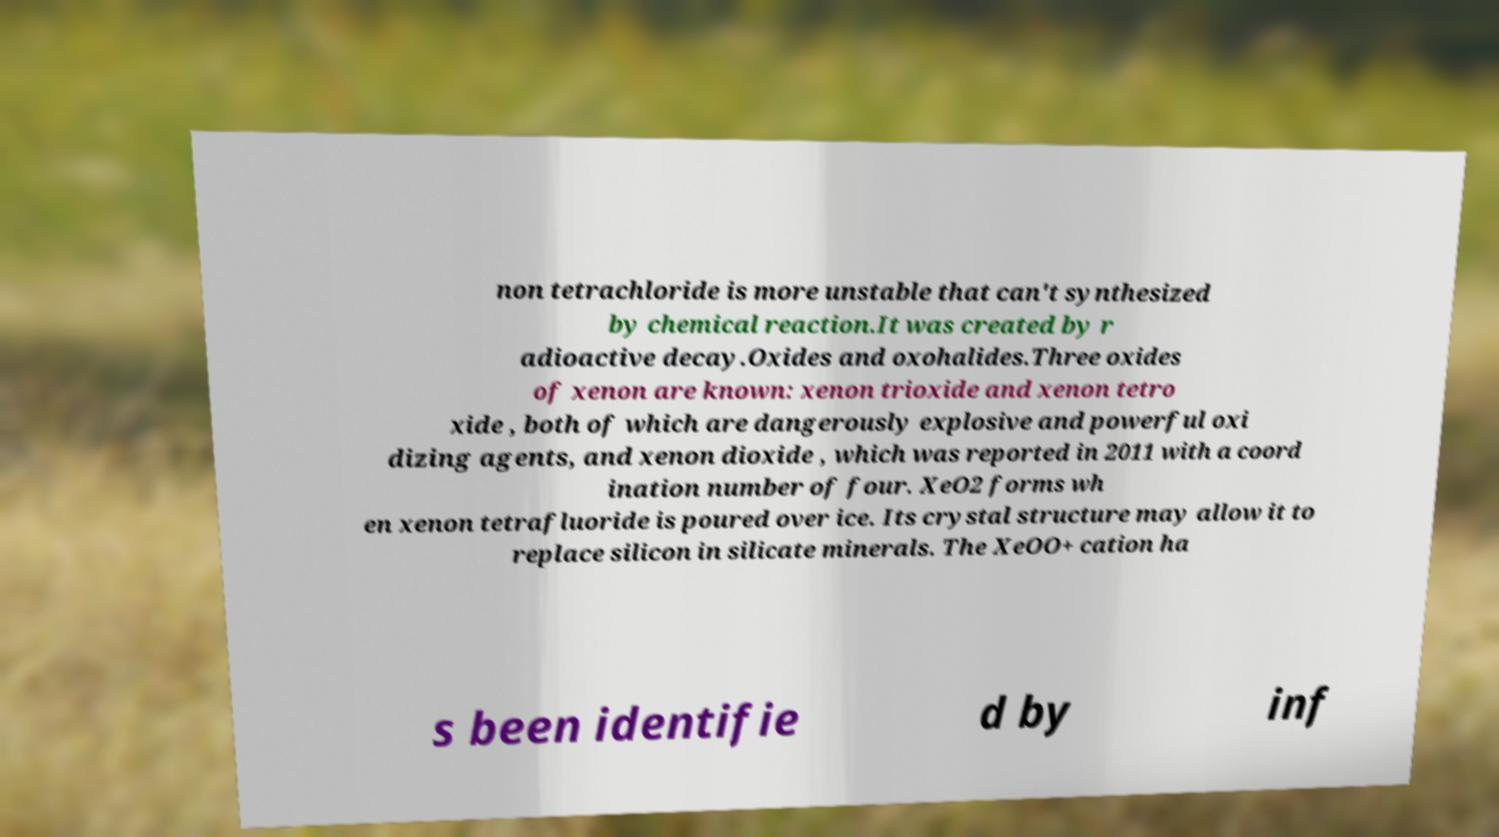Please identify and transcribe the text found in this image. non tetrachloride is more unstable that can't synthesized by chemical reaction.It was created by r adioactive decay.Oxides and oxohalides.Three oxides of xenon are known: xenon trioxide and xenon tetro xide , both of which are dangerously explosive and powerful oxi dizing agents, and xenon dioxide , which was reported in 2011 with a coord ination number of four. XeO2 forms wh en xenon tetrafluoride is poured over ice. Its crystal structure may allow it to replace silicon in silicate minerals. The XeOO+ cation ha s been identifie d by inf 